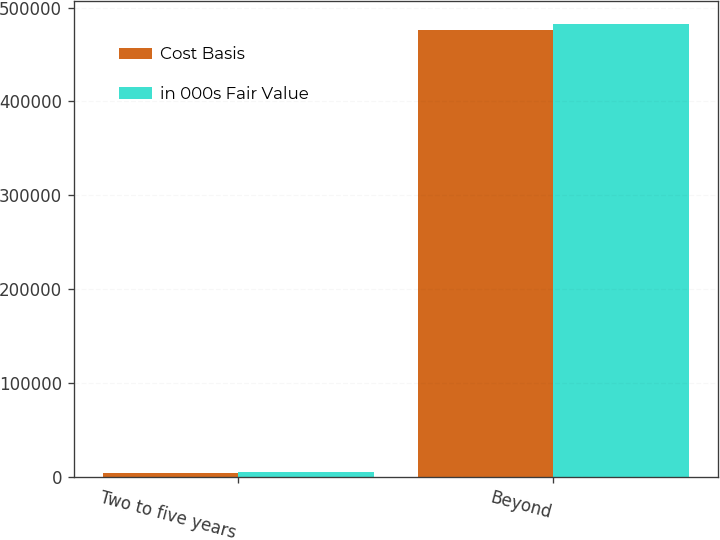Convert chart to OTSL. <chart><loc_0><loc_0><loc_500><loc_500><stacked_bar_chart><ecel><fcel>Two to five years<fcel>Beyond<nl><fcel>Cost Basis<fcel>4178<fcel>476450<nl><fcel>in 000s Fair Value<fcel>4498<fcel>482378<nl></chart> 